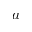<formula> <loc_0><loc_0><loc_500><loc_500>a</formula> 